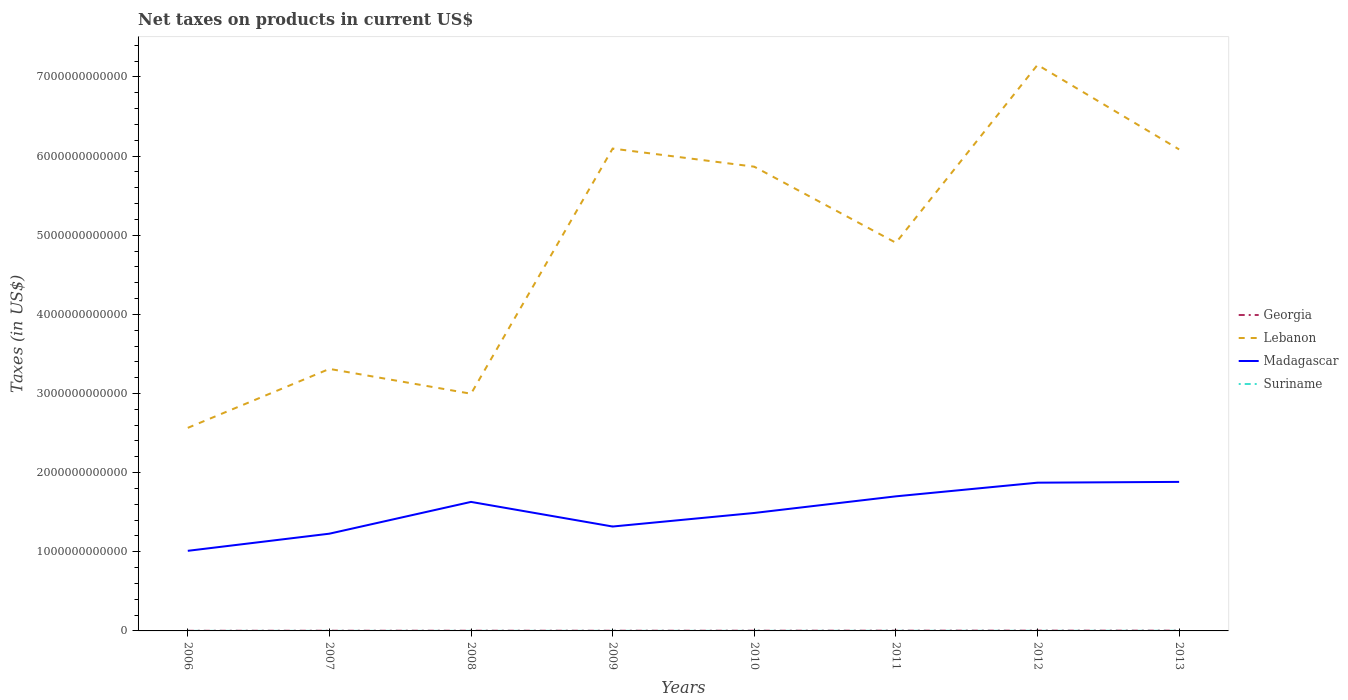Does the line corresponding to Georgia intersect with the line corresponding to Madagascar?
Offer a very short reply. No. Is the number of lines equal to the number of legend labels?
Offer a terse response. Yes. Across all years, what is the maximum net taxes on products in Lebanon?
Ensure brevity in your answer.  2.57e+12. What is the total net taxes on products in Suriname in the graph?
Give a very brief answer. -8.75e+08. What is the difference between the highest and the second highest net taxes on products in Madagascar?
Keep it short and to the point. 8.71e+11. What is the difference between the highest and the lowest net taxes on products in Suriname?
Your response must be concise. 3. Is the net taxes on products in Georgia strictly greater than the net taxes on products in Madagascar over the years?
Provide a succinct answer. Yes. How many years are there in the graph?
Provide a succinct answer. 8. What is the difference between two consecutive major ticks on the Y-axis?
Make the answer very short. 1.00e+12. Does the graph contain any zero values?
Provide a short and direct response. No. Does the graph contain grids?
Give a very brief answer. No. Where does the legend appear in the graph?
Offer a terse response. Center right. How many legend labels are there?
Your response must be concise. 4. How are the legend labels stacked?
Make the answer very short. Vertical. What is the title of the graph?
Your response must be concise. Net taxes on products in current US$. Does "Monaco" appear as one of the legend labels in the graph?
Provide a succinct answer. No. What is the label or title of the X-axis?
Provide a succinct answer. Years. What is the label or title of the Y-axis?
Your answer should be very brief. Taxes (in US$). What is the Taxes (in US$) of Georgia in 2006?
Provide a succinct answer. 1.74e+09. What is the Taxes (in US$) in Lebanon in 2006?
Ensure brevity in your answer.  2.57e+12. What is the Taxes (in US$) of Madagascar in 2006?
Give a very brief answer. 1.01e+12. What is the Taxes (in US$) in Suriname in 2006?
Make the answer very short. 5.51e+08. What is the Taxes (in US$) of Georgia in 2007?
Offer a terse response. 2.38e+09. What is the Taxes (in US$) in Lebanon in 2007?
Provide a short and direct response. 3.31e+12. What is the Taxes (in US$) in Madagascar in 2007?
Keep it short and to the point. 1.23e+12. What is the Taxes (in US$) in Suriname in 2007?
Keep it short and to the point. 6.48e+08. What is the Taxes (in US$) in Georgia in 2008?
Offer a terse response. 2.55e+09. What is the Taxes (in US$) of Lebanon in 2008?
Your response must be concise. 3.00e+12. What is the Taxes (in US$) of Madagascar in 2008?
Provide a short and direct response. 1.63e+12. What is the Taxes (in US$) in Suriname in 2008?
Ensure brevity in your answer.  6.62e+08. What is the Taxes (in US$) in Georgia in 2009?
Offer a very short reply. 2.44e+09. What is the Taxes (in US$) in Lebanon in 2009?
Keep it short and to the point. 6.10e+12. What is the Taxes (in US$) in Madagascar in 2009?
Ensure brevity in your answer.  1.32e+12. What is the Taxes (in US$) of Suriname in 2009?
Offer a terse response. 8.69e+08. What is the Taxes (in US$) in Georgia in 2010?
Provide a short and direct response. 2.73e+09. What is the Taxes (in US$) in Lebanon in 2010?
Make the answer very short. 5.87e+12. What is the Taxes (in US$) of Madagascar in 2010?
Your response must be concise. 1.49e+12. What is the Taxes (in US$) in Suriname in 2010?
Your answer should be compact. 8.55e+08. What is the Taxes (in US$) of Georgia in 2011?
Offer a terse response. 3.37e+09. What is the Taxes (in US$) in Lebanon in 2011?
Your response must be concise. 4.90e+12. What is the Taxes (in US$) of Madagascar in 2011?
Your response must be concise. 1.70e+12. What is the Taxes (in US$) in Suriname in 2011?
Give a very brief answer. 1.32e+09. What is the Taxes (in US$) of Georgia in 2012?
Your answer should be very brief. 3.66e+09. What is the Taxes (in US$) of Lebanon in 2012?
Offer a very short reply. 7.15e+12. What is the Taxes (in US$) in Madagascar in 2012?
Make the answer very short. 1.87e+12. What is the Taxes (in US$) in Suriname in 2012?
Your response must be concise. 1.43e+09. What is the Taxes (in US$) of Georgia in 2013?
Provide a succinct answer. 3.51e+09. What is the Taxes (in US$) in Lebanon in 2013?
Offer a very short reply. 6.08e+12. What is the Taxes (in US$) of Madagascar in 2013?
Your response must be concise. 1.88e+12. What is the Taxes (in US$) in Suriname in 2013?
Provide a short and direct response. 1.54e+09. Across all years, what is the maximum Taxes (in US$) in Georgia?
Provide a short and direct response. 3.66e+09. Across all years, what is the maximum Taxes (in US$) of Lebanon?
Your answer should be compact. 7.15e+12. Across all years, what is the maximum Taxes (in US$) of Madagascar?
Provide a succinct answer. 1.88e+12. Across all years, what is the maximum Taxes (in US$) in Suriname?
Keep it short and to the point. 1.54e+09. Across all years, what is the minimum Taxes (in US$) in Georgia?
Keep it short and to the point. 1.74e+09. Across all years, what is the minimum Taxes (in US$) in Lebanon?
Provide a short and direct response. 2.57e+12. Across all years, what is the minimum Taxes (in US$) of Madagascar?
Provide a short and direct response. 1.01e+12. Across all years, what is the minimum Taxes (in US$) of Suriname?
Offer a terse response. 5.51e+08. What is the total Taxes (in US$) in Georgia in the graph?
Your answer should be compact. 2.24e+1. What is the total Taxes (in US$) of Lebanon in the graph?
Offer a terse response. 3.90e+13. What is the total Taxes (in US$) in Madagascar in the graph?
Keep it short and to the point. 1.21e+13. What is the total Taxes (in US$) in Suriname in the graph?
Make the answer very short. 7.87e+09. What is the difference between the Taxes (in US$) of Georgia in 2006 and that in 2007?
Provide a short and direct response. -6.40e+08. What is the difference between the Taxes (in US$) in Lebanon in 2006 and that in 2007?
Make the answer very short. -7.45e+11. What is the difference between the Taxes (in US$) of Madagascar in 2006 and that in 2007?
Ensure brevity in your answer.  -2.17e+11. What is the difference between the Taxes (in US$) in Suriname in 2006 and that in 2007?
Give a very brief answer. -9.70e+07. What is the difference between the Taxes (in US$) in Georgia in 2006 and that in 2008?
Give a very brief answer. -8.10e+08. What is the difference between the Taxes (in US$) in Lebanon in 2006 and that in 2008?
Your answer should be compact. -4.31e+11. What is the difference between the Taxes (in US$) in Madagascar in 2006 and that in 2008?
Your response must be concise. -6.18e+11. What is the difference between the Taxes (in US$) of Suriname in 2006 and that in 2008?
Keep it short and to the point. -1.11e+08. What is the difference between the Taxes (in US$) in Georgia in 2006 and that in 2009?
Keep it short and to the point. -6.97e+08. What is the difference between the Taxes (in US$) in Lebanon in 2006 and that in 2009?
Make the answer very short. -3.53e+12. What is the difference between the Taxes (in US$) of Madagascar in 2006 and that in 2009?
Your answer should be compact. -3.07e+11. What is the difference between the Taxes (in US$) in Suriname in 2006 and that in 2009?
Offer a very short reply. -3.18e+08. What is the difference between the Taxes (in US$) in Georgia in 2006 and that in 2010?
Ensure brevity in your answer.  -9.86e+08. What is the difference between the Taxes (in US$) in Lebanon in 2006 and that in 2010?
Keep it short and to the point. -3.30e+12. What is the difference between the Taxes (in US$) of Madagascar in 2006 and that in 2010?
Give a very brief answer. -4.78e+11. What is the difference between the Taxes (in US$) in Suriname in 2006 and that in 2010?
Make the answer very short. -3.04e+08. What is the difference between the Taxes (in US$) of Georgia in 2006 and that in 2011?
Give a very brief answer. -1.63e+09. What is the difference between the Taxes (in US$) of Lebanon in 2006 and that in 2011?
Your answer should be compact. -2.34e+12. What is the difference between the Taxes (in US$) in Madagascar in 2006 and that in 2011?
Give a very brief answer. -6.89e+11. What is the difference between the Taxes (in US$) of Suriname in 2006 and that in 2011?
Keep it short and to the point. -7.68e+08. What is the difference between the Taxes (in US$) of Georgia in 2006 and that in 2012?
Give a very brief answer. -1.92e+09. What is the difference between the Taxes (in US$) of Lebanon in 2006 and that in 2012?
Your answer should be compact. -4.59e+12. What is the difference between the Taxes (in US$) of Madagascar in 2006 and that in 2012?
Keep it short and to the point. -8.61e+11. What is the difference between the Taxes (in US$) in Suriname in 2006 and that in 2012?
Give a very brief answer. -8.75e+08. What is the difference between the Taxes (in US$) in Georgia in 2006 and that in 2013?
Make the answer very short. -1.77e+09. What is the difference between the Taxes (in US$) in Lebanon in 2006 and that in 2013?
Provide a short and direct response. -3.52e+12. What is the difference between the Taxes (in US$) of Madagascar in 2006 and that in 2013?
Provide a succinct answer. -8.71e+11. What is the difference between the Taxes (in US$) in Suriname in 2006 and that in 2013?
Your answer should be very brief. -9.91e+08. What is the difference between the Taxes (in US$) of Georgia in 2007 and that in 2008?
Offer a terse response. -1.70e+08. What is the difference between the Taxes (in US$) of Lebanon in 2007 and that in 2008?
Keep it short and to the point. 3.14e+11. What is the difference between the Taxes (in US$) of Madagascar in 2007 and that in 2008?
Ensure brevity in your answer.  -4.02e+11. What is the difference between the Taxes (in US$) in Suriname in 2007 and that in 2008?
Make the answer very short. -1.40e+07. What is the difference between the Taxes (in US$) in Georgia in 2007 and that in 2009?
Your answer should be compact. -5.69e+07. What is the difference between the Taxes (in US$) in Lebanon in 2007 and that in 2009?
Your answer should be very brief. -2.78e+12. What is the difference between the Taxes (in US$) in Madagascar in 2007 and that in 2009?
Ensure brevity in your answer.  -9.04e+1. What is the difference between the Taxes (in US$) of Suriname in 2007 and that in 2009?
Keep it short and to the point. -2.21e+08. What is the difference between the Taxes (in US$) in Georgia in 2007 and that in 2010?
Offer a very short reply. -3.46e+08. What is the difference between the Taxes (in US$) in Lebanon in 2007 and that in 2010?
Offer a terse response. -2.56e+12. What is the difference between the Taxes (in US$) of Madagascar in 2007 and that in 2010?
Ensure brevity in your answer.  -2.62e+11. What is the difference between the Taxes (in US$) of Suriname in 2007 and that in 2010?
Make the answer very short. -2.07e+08. What is the difference between the Taxes (in US$) in Georgia in 2007 and that in 2011?
Your answer should be compact. -9.86e+08. What is the difference between the Taxes (in US$) in Lebanon in 2007 and that in 2011?
Keep it short and to the point. -1.59e+12. What is the difference between the Taxes (in US$) in Madagascar in 2007 and that in 2011?
Give a very brief answer. -4.72e+11. What is the difference between the Taxes (in US$) in Suriname in 2007 and that in 2011?
Your answer should be very brief. -6.71e+08. What is the difference between the Taxes (in US$) in Georgia in 2007 and that in 2012?
Ensure brevity in your answer.  -1.28e+09. What is the difference between the Taxes (in US$) in Lebanon in 2007 and that in 2012?
Keep it short and to the point. -3.84e+12. What is the difference between the Taxes (in US$) of Madagascar in 2007 and that in 2012?
Make the answer very short. -6.45e+11. What is the difference between the Taxes (in US$) in Suriname in 2007 and that in 2012?
Offer a very short reply. -7.78e+08. What is the difference between the Taxes (in US$) in Georgia in 2007 and that in 2013?
Your answer should be compact. -1.13e+09. What is the difference between the Taxes (in US$) in Lebanon in 2007 and that in 2013?
Ensure brevity in your answer.  -2.77e+12. What is the difference between the Taxes (in US$) in Madagascar in 2007 and that in 2013?
Offer a very short reply. -6.54e+11. What is the difference between the Taxes (in US$) in Suriname in 2007 and that in 2013?
Provide a succinct answer. -8.94e+08. What is the difference between the Taxes (in US$) of Georgia in 2008 and that in 2009?
Offer a terse response. 1.13e+08. What is the difference between the Taxes (in US$) in Lebanon in 2008 and that in 2009?
Your response must be concise. -3.10e+12. What is the difference between the Taxes (in US$) of Madagascar in 2008 and that in 2009?
Make the answer very short. 3.11e+11. What is the difference between the Taxes (in US$) of Suriname in 2008 and that in 2009?
Your answer should be very brief. -2.07e+08. What is the difference between the Taxes (in US$) in Georgia in 2008 and that in 2010?
Your answer should be very brief. -1.76e+08. What is the difference between the Taxes (in US$) in Lebanon in 2008 and that in 2010?
Offer a terse response. -2.87e+12. What is the difference between the Taxes (in US$) of Madagascar in 2008 and that in 2010?
Ensure brevity in your answer.  1.40e+11. What is the difference between the Taxes (in US$) of Suriname in 2008 and that in 2010?
Provide a succinct answer. -1.93e+08. What is the difference between the Taxes (in US$) in Georgia in 2008 and that in 2011?
Your response must be concise. -8.16e+08. What is the difference between the Taxes (in US$) in Lebanon in 2008 and that in 2011?
Offer a very short reply. -1.91e+12. What is the difference between the Taxes (in US$) in Madagascar in 2008 and that in 2011?
Make the answer very short. -7.04e+1. What is the difference between the Taxes (in US$) in Suriname in 2008 and that in 2011?
Ensure brevity in your answer.  -6.57e+08. What is the difference between the Taxes (in US$) in Georgia in 2008 and that in 2012?
Your answer should be compact. -1.11e+09. What is the difference between the Taxes (in US$) in Lebanon in 2008 and that in 2012?
Offer a terse response. -4.16e+12. What is the difference between the Taxes (in US$) in Madagascar in 2008 and that in 2012?
Give a very brief answer. -2.43e+11. What is the difference between the Taxes (in US$) in Suriname in 2008 and that in 2012?
Provide a short and direct response. -7.64e+08. What is the difference between the Taxes (in US$) in Georgia in 2008 and that in 2013?
Ensure brevity in your answer.  -9.59e+08. What is the difference between the Taxes (in US$) of Lebanon in 2008 and that in 2013?
Offer a terse response. -3.09e+12. What is the difference between the Taxes (in US$) of Madagascar in 2008 and that in 2013?
Ensure brevity in your answer.  -2.53e+11. What is the difference between the Taxes (in US$) of Suriname in 2008 and that in 2013?
Offer a very short reply. -8.80e+08. What is the difference between the Taxes (in US$) in Georgia in 2009 and that in 2010?
Provide a succinct answer. -2.89e+08. What is the difference between the Taxes (in US$) of Lebanon in 2009 and that in 2010?
Give a very brief answer. 2.29e+11. What is the difference between the Taxes (in US$) of Madagascar in 2009 and that in 2010?
Provide a succinct answer. -1.71e+11. What is the difference between the Taxes (in US$) in Suriname in 2009 and that in 2010?
Offer a very short reply. 1.40e+07. What is the difference between the Taxes (in US$) of Georgia in 2009 and that in 2011?
Keep it short and to the point. -9.29e+08. What is the difference between the Taxes (in US$) of Lebanon in 2009 and that in 2011?
Offer a terse response. 1.19e+12. What is the difference between the Taxes (in US$) of Madagascar in 2009 and that in 2011?
Your answer should be very brief. -3.81e+11. What is the difference between the Taxes (in US$) in Suriname in 2009 and that in 2011?
Your answer should be very brief. -4.50e+08. What is the difference between the Taxes (in US$) in Georgia in 2009 and that in 2012?
Your response must be concise. -1.22e+09. What is the difference between the Taxes (in US$) in Lebanon in 2009 and that in 2012?
Your answer should be compact. -1.06e+12. What is the difference between the Taxes (in US$) of Madagascar in 2009 and that in 2012?
Provide a short and direct response. -5.54e+11. What is the difference between the Taxes (in US$) of Suriname in 2009 and that in 2012?
Offer a very short reply. -5.57e+08. What is the difference between the Taxes (in US$) in Georgia in 2009 and that in 2013?
Ensure brevity in your answer.  -1.07e+09. What is the difference between the Taxes (in US$) in Lebanon in 2009 and that in 2013?
Provide a short and direct response. 1.06e+1. What is the difference between the Taxes (in US$) in Madagascar in 2009 and that in 2013?
Ensure brevity in your answer.  -5.64e+11. What is the difference between the Taxes (in US$) in Suriname in 2009 and that in 2013?
Keep it short and to the point. -6.73e+08. What is the difference between the Taxes (in US$) of Georgia in 2010 and that in 2011?
Offer a very short reply. -6.40e+08. What is the difference between the Taxes (in US$) of Lebanon in 2010 and that in 2011?
Your answer should be very brief. 9.61e+11. What is the difference between the Taxes (in US$) in Madagascar in 2010 and that in 2011?
Give a very brief answer. -2.10e+11. What is the difference between the Taxes (in US$) in Suriname in 2010 and that in 2011?
Make the answer very short. -4.64e+08. What is the difference between the Taxes (in US$) in Georgia in 2010 and that in 2012?
Your response must be concise. -9.33e+08. What is the difference between the Taxes (in US$) in Lebanon in 2010 and that in 2012?
Ensure brevity in your answer.  -1.29e+12. What is the difference between the Taxes (in US$) of Madagascar in 2010 and that in 2012?
Keep it short and to the point. -3.83e+11. What is the difference between the Taxes (in US$) of Suriname in 2010 and that in 2012?
Make the answer very short. -5.71e+08. What is the difference between the Taxes (in US$) in Georgia in 2010 and that in 2013?
Make the answer very short. -7.83e+08. What is the difference between the Taxes (in US$) in Lebanon in 2010 and that in 2013?
Make the answer very short. -2.18e+11. What is the difference between the Taxes (in US$) in Madagascar in 2010 and that in 2013?
Your answer should be compact. -3.93e+11. What is the difference between the Taxes (in US$) in Suriname in 2010 and that in 2013?
Provide a short and direct response. -6.87e+08. What is the difference between the Taxes (in US$) of Georgia in 2011 and that in 2012?
Offer a very short reply. -2.93e+08. What is the difference between the Taxes (in US$) of Lebanon in 2011 and that in 2012?
Offer a very short reply. -2.25e+12. What is the difference between the Taxes (in US$) of Madagascar in 2011 and that in 2012?
Your answer should be compact. -1.73e+11. What is the difference between the Taxes (in US$) of Suriname in 2011 and that in 2012?
Give a very brief answer. -1.07e+08. What is the difference between the Taxes (in US$) in Georgia in 2011 and that in 2013?
Offer a terse response. -1.44e+08. What is the difference between the Taxes (in US$) of Lebanon in 2011 and that in 2013?
Make the answer very short. -1.18e+12. What is the difference between the Taxes (in US$) in Madagascar in 2011 and that in 2013?
Offer a terse response. -1.83e+11. What is the difference between the Taxes (in US$) of Suriname in 2011 and that in 2013?
Give a very brief answer. -2.23e+08. What is the difference between the Taxes (in US$) in Georgia in 2012 and that in 2013?
Offer a terse response. 1.50e+08. What is the difference between the Taxes (in US$) of Lebanon in 2012 and that in 2013?
Ensure brevity in your answer.  1.07e+12. What is the difference between the Taxes (in US$) of Madagascar in 2012 and that in 2013?
Provide a short and direct response. -9.89e+09. What is the difference between the Taxes (in US$) of Suriname in 2012 and that in 2013?
Your answer should be very brief. -1.16e+08. What is the difference between the Taxes (in US$) in Georgia in 2006 and the Taxes (in US$) in Lebanon in 2007?
Provide a short and direct response. -3.31e+12. What is the difference between the Taxes (in US$) of Georgia in 2006 and the Taxes (in US$) of Madagascar in 2007?
Ensure brevity in your answer.  -1.23e+12. What is the difference between the Taxes (in US$) of Georgia in 2006 and the Taxes (in US$) of Suriname in 2007?
Keep it short and to the point. 1.10e+09. What is the difference between the Taxes (in US$) in Lebanon in 2006 and the Taxes (in US$) in Madagascar in 2007?
Make the answer very short. 1.34e+12. What is the difference between the Taxes (in US$) of Lebanon in 2006 and the Taxes (in US$) of Suriname in 2007?
Offer a very short reply. 2.57e+12. What is the difference between the Taxes (in US$) of Madagascar in 2006 and the Taxes (in US$) of Suriname in 2007?
Offer a very short reply. 1.01e+12. What is the difference between the Taxes (in US$) in Georgia in 2006 and the Taxes (in US$) in Lebanon in 2008?
Your answer should be compact. -3.00e+12. What is the difference between the Taxes (in US$) in Georgia in 2006 and the Taxes (in US$) in Madagascar in 2008?
Offer a terse response. -1.63e+12. What is the difference between the Taxes (in US$) of Georgia in 2006 and the Taxes (in US$) of Suriname in 2008?
Provide a succinct answer. 1.08e+09. What is the difference between the Taxes (in US$) in Lebanon in 2006 and the Taxes (in US$) in Madagascar in 2008?
Your answer should be compact. 9.36e+11. What is the difference between the Taxes (in US$) in Lebanon in 2006 and the Taxes (in US$) in Suriname in 2008?
Your answer should be compact. 2.57e+12. What is the difference between the Taxes (in US$) of Madagascar in 2006 and the Taxes (in US$) of Suriname in 2008?
Your response must be concise. 1.01e+12. What is the difference between the Taxes (in US$) of Georgia in 2006 and the Taxes (in US$) of Lebanon in 2009?
Give a very brief answer. -6.09e+12. What is the difference between the Taxes (in US$) in Georgia in 2006 and the Taxes (in US$) in Madagascar in 2009?
Give a very brief answer. -1.32e+12. What is the difference between the Taxes (in US$) of Georgia in 2006 and the Taxes (in US$) of Suriname in 2009?
Ensure brevity in your answer.  8.74e+08. What is the difference between the Taxes (in US$) in Lebanon in 2006 and the Taxes (in US$) in Madagascar in 2009?
Offer a terse response. 1.25e+12. What is the difference between the Taxes (in US$) of Lebanon in 2006 and the Taxes (in US$) of Suriname in 2009?
Make the answer very short. 2.57e+12. What is the difference between the Taxes (in US$) of Madagascar in 2006 and the Taxes (in US$) of Suriname in 2009?
Provide a succinct answer. 1.01e+12. What is the difference between the Taxes (in US$) of Georgia in 2006 and the Taxes (in US$) of Lebanon in 2010?
Give a very brief answer. -5.86e+12. What is the difference between the Taxes (in US$) in Georgia in 2006 and the Taxes (in US$) in Madagascar in 2010?
Your answer should be very brief. -1.49e+12. What is the difference between the Taxes (in US$) of Georgia in 2006 and the Taxes (in US$) of Suriname in 2010?
Ensure brevity in your answer.  8.88e+08. What is the difference between the Taxes (in US$) in Lebanon in 2006 and the Taxes (in US$) in Madagascar in 2010?
Give a very brief answer. 1.08e+12. What is the difference between the Taxes (in US$) in Lebanon in 2006 and the Taxes (in US$) in Suriname in 2010?
Provide a short and direct response. 2.57e+12. What is the difference between the Taxes (in US$) of Madagascar in 2006 and the Taxes (in US$) of Suriname in 2010?
Give a very brief answer. 1.01e+12. What is the difference between the Taxes (in US$) of Georgia in 2006 and the Taxes (in US$) of Lebanon in 2011?
Provide a short and direct response. -4.90e+12. What is the difference between the Taxes (in US$) in Georgia in 2006 and the Taxes (in US$) in Madagascar in 2011?
Make the answer very short. -1.70e+12. What is the difference between the Taxes (in US$) of Georgia in 2006 and the Taxes (in US$) of Suriname in 2011?
Offer a terse response. 4.24e+08. What is the difference between the Taxes (in US$) of Lebanon in 2006 and the Taxes (in US$) of Madagascar in 2011?
Keep it short and to the point. 8.65e+11. What is the difference between the Taxes (in US$) in Lebanon in 2006 and the Taxes (in US$) in Suriname in 2011?
Provide a succinct answer. 2.56e+12. What is the difference between the Taxes (in US$) in Madagascar in 2006 and the Taxes (in US$) in Suriname in 2011?
Make the answer very short. 1.01e+12. What is the difference between the Taxes (in US$) in Georgia in 2006 and the Taxes (in US$) in Lebanon in 2012?
Offer a terse response. -7.15e+12. What is the difference between the Taxes (in US$) in Georgia in 2006 and the Taxes (in US$) in Madagascar in 2012?
Provide a short and direct response. -1.87e+12. What is the difference between the Taxes (in US$) in Georgia in 2006 and the Taxes (in US$) in Suriname in 2012?
Offer a very short reply. 3.17e+08. What is the difference between the Taxes (in US$) in Lebanon in 2006 and the Taxes (in US$) in Madagascar in 2012?
Offer a terse response. 6.93e+11. What is the difference between the Taxes (in US$) in Lebanon in 2006 and the Taxes (in US$) in Suriname in 2012?
Offer a terse response. 2.56e+12. What is the difference between the Taxes (in US$) in Madagascar in 2006 and the Taxes (in US$) in Suriname in 2012?
Your answer should be very brief. 1.01e+12. What is the difference between the Taxes (in US$) in Georgia in 2006 and the Taxes (in US$) in Lebanon in 2013?
Offer a very short reply. -6.08e+12. What is the difference between the Taxes (in US$) in Georgia in 2006 and the Taxes (in US$) in Madagascar in 2013?
Make the answer very short. -1.88e+12. What is the difference between the Taxes (in US$) of Georgia in 2006 and the Taxes (in US$) of Suriname in 2013?
Offer a terse response. 2.01e+08. What is the difference between the Taxes (in US$) of Lebanon in 2006 and the Taxes (in US$) of Madagascar in 2013?
Offer a terse response. 6.83e+11. What is the difference between the Taxes (in US$) in Lebanon in 2006 and the Taxes (in US$) in Suriname in 2013?
Offer a terse response. 2.56e+12. What is the difference between the Taxes (in US$) of Madagascar in 2006 and the Taxes (in US$) of Suriname in 2013?
Offer a terse response. 1.01e+12. What is the difference between the Taxes (in US$) in Georgia in 2007 and the Taxes (in US$) in Lebanon in 2008?
Your answer should be compact. -2.99e+12. What is the difference between the Taxes (in US$) of Georgia in 2007 and the Taxes (in US$) of Madagascar in 2008?
Offer a terse response. -1.63e+12. What is the difference between the Taxes (in US$) in Georgia in 2007 and the Taxes (in US$) in Suriname in 2008?
Keep it short and to the point. 1.72e+09. What is the difference between the Taxes (in US$) in Lebanon in 2007 and the Taxes (in US$) in Madagascar in 2008?
Ensure brevity in your answer.  1.68e+12. What is the difference between the Taxes (in US$) of Lebanon in 2007 and the Taxes (in US$) of Suriname in 2008?
Your response must be concise. 3.31e+12. What is the difference between the Taxes (in US$) of Madagascar in 2007 and the Taxes (in US$) of Suriname in 2008?
Offer a terse response. 1.23e+12. What is the difference between the Taxes (in US$) of Georgia in 2007 and the Taxes (in US$) of Lebanon in 2009?
Provide a short and direct response. -6.09e+12. What is the difference between the Taxes (in US$) of Georgia in 2007 and the Taxes (in US$) of Madagascar in 2009?
Offer a terse response. -1.32e+12. What is the difference between the Taxes (in US$) in Georgia in 2007 and the Taxes (in US$) in Suriname in 2009?
Your response must be concise. 1.51e+09. What is the difference between the Taxes (in US$) of Lebanon in 2007 and the Taxes (in US$) of Madagascar in 2009?
Your response must be concise. 1.99e+12. What is the difference between the Taxes (in US$) in Lebanon in 2007 and the Taxes (in US$) in Suriname in 2009?
Provide a short and direct response. 3.31e+12. What is the difference between the Taxes (in US$) in Madagascar in 2007 and the Taxes (in US$) in Suriname in 2009?
Make the answer very short. 1.23e+12. What is the difference between the Taxes (in US$) of Georgia in 2007 and the Taxes (in US$) of Lebanon in 2010?
Offer a terse response. -5.86e+12. What is the difference between the Taxes (in US$) of Georgia in 2007 and the Taxes (in US$) of Madagascar in 2010?
Ensure brevity in your answer.  -1.49e+12. What is the difference between the Taxes (in US$) in Georgia in 2007 and the Taxes (in US$) in Suriname in 2010?
Make the answer very short. 1.53e+09. What is the difference between the Taxes (in US$) of Lebanon in 2007 and the Taxes (in US$) of Madagascar in 2010?
Your answer should be very brief. 1.82e+12. What is the difference between the Taxes (in US$) in Lebanon in 2007 and the Taxes (in US$) in Suriname in 2010?
Offer a very short reply. 3.31e+12. What is the difference between the Taxes (in US$) in Madagascar in 2007 and the Taxes (in US$) in Suriname in 2010?
Keep it short and to the point. 1.23e+12. What is the difference between the Taxes (in US$) in Georgia in 2007 and the Taxes (in US$) in Lebanon in 2011?
Provide a short and direct response. -4.90e+12. What is the difference between the Taxes (in US$) of Georgia in 2007 and the Taxes (in US$) of Madagascar in 2011?
Your answer should be compact. -1.70e+12. What is the difference between the Taxes (in US$) of Georgia in 2007 and the Taxes (in US$) of Suriname in 2011?
Ensure brevity in your answer.  1.06e+09. What is the difference between the Taxes (in US$) of Lebanon in 2007 and the Taxes (in US$) of Madagascar in 2011?
Provide a succinct answer. 1.61e+12. What is the difference between the Taxes (in US$) in Lebanon in 2007 and the Taxes (in US$) in Suriname in 2011?
Your response must be concise. 3.31e+12. What is the difference between the Taxes (in US$) in Madagascar in 2007 and the Taxes (in US$) in Suriname in 2011?
Offer a very short reply. 1.23e+12. What is the difference between the Taxes (in US$) in Georgia in 2007 and the Taxes (in US$) in Lebanon in 2012?
Keep it short and to the point. -7.15e+12. What is the difference between the Taxes (in US$) in Georgia in 2007 and the Taxes (in US$) in Madagascar in 2012?
Make the answer very short. -1.87e+12. What is the difference between the Taxes (in US$) of Georgia in 2007 and the Taxes (in US$) of Suriname in 2012?
Offer a terse response. 9.57e+08. What is the difference between the Taxes (in US$) in Lebanon in 2007 and the Taxes (in US$) in Madagascar in 2012?
Provide a short and direct response. 1.44e+12. What is the difference between the Taxes (in US$) of Lebanon in 2007 and the Taxes (in US$) of Suriname in 2012?
Provide a short and direct response. 3.31e+12. What is the difference between the Taxes (in US$) in Madagascar in 2007 and the Taxes (in US$) in Suriname in 2012?
Ensure brevity in your answer.  1.23e+12. What is the difference between the Taxes (in US$) of Georgia in 2007 and the Taxes (in US$) of Lebanon in 2013?
Provide a succinct answer. -6.08e+12. What is the difference between the Taxes (in US$) of Georgia in 2007 and the Taxes (in US$) of Madagascar in 2013?
Provide a succinct answer. -1.88e+12. What is the difference between the Taxes (in US$) in Georgia in 2007 and the Taxes (in US$) in Suriname in 2013?
Offer a very short reply. 8.41e+08. What is the difference between the Taxes (in US$) in Lebanon in 2007 and the Taxes (in US$) in Madagascar in 2013?
Offer a very short reply. 1.43e+12. What is the difference between the Taxes (in US$) of Lebanon in 2007 and the Taxes (in US$) of Suriname in 2013?
Your answer should be compact. 3.31e+12. What is the difference between the Taxes (in US$) of Madagascar in 2007 and the Taxes (in US$) of Suriname in 2013?
Keep it short and to the point. 1.23e+12. What is the difference between the Taxes (in US$) in Georgia in 2008 and the Taxes (in US$) in Lebanon in 2009?
Ensure brevity in your answer.  -6.09e+12. What is the difference between the Taxes (in US$) in Georgia in 2008 and the Taxes (in US$) in Madagascar in 2009?
Provide a short and direct response. -1.32e+12. What is the difference between the Taxes (in US$) of Georgia in 2008 and the Taxes (in US$) of Suriname in 2009?
Give a very brief answer. 1.68e+09. What is the difference between the Taxes (in US$) of Lebanon in 2008 and the Taxes (in US$) of Madagascar in 2009?
Keep it short and to the point. 1.68e+12. What is the difference between the Taxes (in US$) in Lebanon in 2008 and the Taxes (in US$) in Suriname in 2009?
Provide a succinct answer. 3.00e+12. What is the difference between the Taxes (in US$) of Madagascar in 2008 and the Taxes (in US$) of Suriname in 2009?
Keep it short and to the point. 1.63e+12. What is the difference between the Taxes (in US$) in Georgia in 2008 and the Taxes (in US$) in Lebanon in 2010?
Make the answer very short. -5.86e+12. What is the difference between the Taxes (in US$) in Georgia in 2008 and the Taxes (in US$) in Madagascar in 2010?
Keep it short and to the point. -1.49e+12. What is the difference between the Taxes (in US$) in Georgia in 2008 and the Taxes (in US$) in Suriname in 2010?
Offer a terse response. 1.70e+09. What is the difference between the Taxes (in US$) of Lebanon in 2008 and the Taxes (in US$) of Madagascar in 2010?
Keep it short and to the point. 1.51e+12. What is the difference between the Taxes (in US$) of Lebanon in 2008 and the Taxes (in US$) of Suriname in 2010?
Keep it short and to the point. 3.00e+12. What is the difference between the Taxes (in US$) of Madagascar in 2008 and the Taxes (in US$) of Suriname in 2010?
Your answer should be compact. 1.63e+12. What is the difference between the Taxes (in US$) of Georgia in 2008 and the Taxes (in US$) of Lebanon in 2011?
Make the answer very short. -4.90e+12. What is the difference between the Taxes (in US$) in Georgia in 2008 and the Taxes (in US$) in Madagascar in 2011?
Offer a terse response. -1.70e+12. What is the difference between the Taxes (in US$) of Georgia in 2008 and the Taxes (in US$) of Suriname in 2011?
Your response must be concise. 1.23e+09. What is the difference between the Taxes (in US$) of Lebanon in 2008 and the Taxes (in US$) of Madagascar in 2011?
Offer a very short reply. 1.30e+12. What is the difference between the Taxes (in US$) in Lebanon in 2008 and the Taxes (in US$) in Suriname in 2011?
Give a very brief answer. 3.00e+12. What is the difference between the Taxes (in US$) in Madagascar in 2008 and the Taxes (in US$) in Suriname in 2011?
Keep it short and to the point. 1.63e+12. What is the difference between the Taxes (in US$) of Georgia in 2008 and the Taxes (in US$) of Lebanon in 2012?
Provide a short and direct response. -7.15e+12. What is the difference between the Taxes (in US$) in Georgia in 2008 and the Taxes (in US$) in Madagascar in 2012?
Give a very brief answer. -1.87e+12. What is the difference between the Taxes (in US$) in Georgia in 2008 and the Taxes (in US$) in Suriname in 2012?
Make the answer very short. 1.13e+09. What is the difference between the Taxes (in US$) in Lebanon in 2008 and the Taxes (in US$) in Madagascar in 2012?
Make the answer very short. 1.12e+12. What is the difference between the Taxes (in US$) of Lebanon in 2008 and the Taxes (in US$) of Suriname in 2012?
Your response must be concise. 3.00e+12. What is the difference between the Taxes (in US$) of Madagascar in 2008 and the Taxes (in US$) of Suriname in 2012?
Give a very brief answer. 1.63e+12. What is the difference between the Taxes (in US$) in Georgia in 2008 and the Taxes (in US$) in Lebanon in 2013?
Your answer should be very brief. -6.08e+12. What is the difference between the Taxes (in US$) of Georgia in 2008 and the Taxes (in US$) of Madagascar in 2013?
Your response must be concise. -1.88e+12. What is the difference between the Taxes (in US$) of Georgia in 2008 and the Taxes (in US$) of Suriname in 2013?
Offer a terse response. 1.01e+09. What is the difference between the Taxes (in US$) of Lebanon in 2008 and the Taxes (in US$) of Madagascar in 2013?
Your answer should be compact. 1.11e+12. What is the difference between the Taxes (in US$) of Lebanon in 2008 and the Taxes (in US$) of Suriname in 2013?
Provide a short and direct response. 3.00e+12. What is the difference between the Taxes (in US$) in Madagascar in 2008 and the Taxes (in US$) in Suriname in 2013?
Provide a succinct answer. 1.63e+12. What is the difference between the Taxes (in US$) in Georgia in 2009 and the Taxes (in US$) in Lebanon in 2010?
Provide a succinct answer. -5.86e+12. What is the difference between the Taxes (in US$) of Georgia in 2009 and the Taxes (in US$) of Madagascar in 2010?
Your response must be concise. -1.49e+12. What is the difference between the Taxes (in US$) of Georgia in 2009 and the Taxes (in US$) of Suriname in 2010?
Provide a short and direct response. 1.58e+09. What is the difference between the Taxes (in US$) of Lebanon in 2009 and the Taxes (in US$) of Madagascar in 2010?
Offer a very short reply. 4.60e+12. What is the difference between the Taxes (in US$) in Lebanon in 2009 and the Taxes (in US$) in Suriname in 2010?
Your answer should be compact. 6.09e+12. What is the difference between the Taxes (in US$) of Madagascar in 2009 and the Taxes (in US$) of Suriname in 2010?
Offer a very short reply. 1.32e+12. What is the difference between the Taxes (in US$) of Georgia in 2009 and the Taxes (in US$) of Lebanon in 2011?
Ensure brevity in your answer.  -4.90e+12. What is the difference between the Taxes (in US$) in Georgia in 2009 and the Taxes (in US$) in Madagascar in 2011?
Offer a very short reply. -1.70e+12. What is the difference between the Taxes (in US$) of Georgia in 2009 and the Taxes (in US$) of Suriname in 2011?
Ensure brevity in your answer.  1.12e+09. What is the difference between the Taxes (in US$) in Lebanon in 2009 and the Taxes (in US$) in Madagascar in 2011?
Offer a terse response. 4.39e+12. What is the difference between the Taxes (in US$) of Lebanon in 2009 and the Taxes (in US$) of Suriname in 2011?
Give a very brief answer. 6.09e+12. What is the difference between the Taxes (in US$) in Madagascar in 2009 and the Taxes (in US$) in Suriname in 2011?
Your answer should be compact. 1.32e+12. What is the difference between the Taxes (in US$) in Georgia in 2009 and the Taxes (in US$) in Lebanon in 2012?
Offer a very short reply. -7.15e+12. What is the difference between the Taxes (in US$) in Georgia in 2009 and the Taxes (in US$) in Madagascar in 2012?
Offer a very short reply. -1.87e+12. What is the difference between the Taxes (in US$) of Georgia in 2009 and the Taxes (in US$) of Suriname in 2012?
Offer a terse response. 1.01e+09. What is the difference between the Taxes (in US$) in Lebanon in 2009 and the Taxes (in US$) in Madagascar in 2012?
Make the answer very short. 4.22e+12. What is the difference between the Taxes (in US$) in Lebanon in 2009 and the Taxes (in US$) in Suriname in 2012?
Provide a succinct answer. 6.09e+12. What is the difference between the Taxes (in US$) in Madagascar in 2009 and the Taxes (in US$) in Suriname in 2012?
Your response must be concise. 1.32e+12. What is the difference between the Taxes (in US$) of Georgia in 2009 and the Taxes (in US$) of Lebanon in 2013?
Offer a terse response. -6.08e+12. What is the difference between the Taxes (in US$) in Georgia in 2009 and the Taxes (in US$) in Madagascar in 2013?
Provide a short and direct response. -1.88e+12. What is the difference between the Taxes (in US$) of Georgia in 2009 and the Taxes (in US$) of Suriname in 2013?
Give a very brief answer. 8.98e+08. What is the difference between the Taxes (in US$) of Lebanon in 2009 and the Taxes (in US$) of Madagascar in 2013?
Keep it short and to the point. 4.21e+12. What is the difference between the Taxes (in US$) of Lebanon in 2009 and the Taxes (in US$) of Suriname in 2013?
Your response must be concise. 6.09e+12. What is the difference between the Taxes (in US$) in Madagascar in 2009 and the Taxes (in US$) in Suriname in 2013?
Ensure brevity in your answer.  1.32e+12. What is the difference between the Taxes (in US$) of Georgia in 2010 and the Taxes (in US$) of Lebanon in 2011?
Offer a terse response. -4.90e+12. What is the difference between the Taxes (in US$) of Georgia in 2010 and the Taxes (in US$) of Madagascar in 2011?
Ensure brevity in your answer.  -1.70e+12. What is the difference between the Taxes (in US$) of Georgia in 2010 and the Taxes (in US$) of Suriname in 2011?
Your answer should be very brief. 1.41e+09. What is the difference between the Taxes (in US$) in Lebanon in 2010 and the Taxes (in US$) in Madagascar in 2011?
Your response must be concise. 4.17e+12. What is the difference between the Taxes (in US$) in Lebanon in 2010 and the Taxes (in US$) in Suriname in 2011?
Offer a terse response. 5.86e+12. What is the difference between the Taxes (in US$) in Madagascar in 2010 and the Taxes (in US$) in Suriname in 2011?
Ensure brevity in your answer.  1.49e+12. What is the difference between the Taxes (in US$) of Georgia in 2010 and the Taxes (in US$) of Lebanon in 2012?
Your response must be concise. -7.15e+12. What is the difference between the Taxes (in US$) of Georgia in 2010 and the Taxes (in US$) of Madagascar in 2012?
Provide a short and direct response. -1.87e+12. What is the difference between the Taxes (in US$) of Georgia in 2010 and the Taxes (in US$) of Suriname in 2012?
Keep it short and to the point. 1.30e+09. What is the difference between the Taxes (in US$) of Lebanon in 2010 and the Taxes (in US$) of Madagascar in 2012?
Your answer should be compact. 3.99e+12. What is the difference between the Taxes (in US$) in Lebanon in 2010 and the Taxes (in US$) in Suriname in 2012?
Keep it short and to the point. 5.86e+12. What is the difference between the Taxes (in US$) in Madagascar in 2010 and the Taxes (in US$) in Suriname in 2012?
Provide a succinct answer. 1.49e+12. What is the difference between the Taxes (in US$) of Georgia in 2010 and the Taxes (in US$) of Lebanon in 2013?
Make the answer very short. -6.08e+12. What is the difference between the Taxes (in US$) in Georgia in 2010 and the Taxes (in US$) in Madagascar in 2013?
Provide a short and direct response. -1.88e+12. What is the difference between the Taxes (in US$) of Georgia in 2010 and the Taxes (in US$) of Suriname in 2013?
Your response must be concise. 1.19e+09. What is the difference between the Taxes (in US$) in Lebanon in 2010 and the Taxes (in US$) in Madagascar in 2013?
Your response must be concise. 3.98e+12. What is the difference between the Taxes (in US$) in Lebanon in 2010 and the Taxes (in US$) in Suriname in 2013?
Ensure brevity in your answer.  5.86e+12. What is the difference between the Taxes (in US$) of Madagascar in 2010 and the Taxes (in US$) of Suriname in 2013?
Ensure brevity in your answer.  1.49e+12. What is the difference between the Taxes (in US$) of Georgia in 2011 and the Taxes (in US$) of Lebanon in 2012?
Your answer should be very brief. -7.15e+12. What is the difference between the Taxes (in US$) in Georgia in 2011 and the Taxes (in US$) in Madagascar in 2012?
Your answer should be very brief. -1.87e+12. What is the difference between the Taxes (in US$) in Georgia in 2011 and the Taxes (in US$) in Suriname in 2012?
Make the answer very short. 1.94e+09. What is the difference between the Taxes (in US$) of Lebanon in 2011 and the Taxes (in US$) of Madagascar in 2012?
Provide a short and direct response. 3.03e+12. What is the difference between the Taxes (in US$) of Lebanon in 2011 and the Taxes (in US$) of Suriname in 2012?
Ensure brevity in your answer.  4.90e+12. What is the difference between the Taxes (in US$) in Madagascar in 2011 and the Taxes (in US$) in Suriname in 2012?
Your response must be concise. 1.70e+12. What is the difference between the Taxes (in US$) in Georgia in 2011 and the Taxes (in US$) in Lebanon in 2013?
Your answer should be very brief. -6.08e+12. What is the difference between the Taxes (in US$) in Georgia in 2011 and the Taxes (in US$) in Madagascar in 2013?
Give a very brief answer. -1.88e+12. What is the difference between the Taxes (in US$) of Georgia in 2011 and the Taxes (in US$) of Suriname in 2013?
Ensure brevity in your answer.  1.83e+09. What is the difference between the Taxes (in US$) in Lebanon in 2011 and the Taxes (in US$) in Madagascar in 2013?
Your response must be concise. 3.02e+12. What is the difference between the Taxes (in US$) in Lebanon in 2011 and the Taxes (in US$) in Suriname in 2013?
Provide a succinct answer. 4.90e+12. What is the difference between the Taxes (in US$) in Madagascar in 2011 and the Taxes (in US$) in Suriname in 2013?
Your answer should be very brief. 1.70e+12. What is the difference between the Taxes (in US$) of Georgia in 2012 and the Taxes (in US$) of Lebanon in 2013?
Provide a succinct answer. -6.08e+12. What is the difference between the Taxes (in US$) in Georgia in 2012 and the Taxes (in US$) in Madagascar in 2013?
Give a very brief answer. -1.88e+12. What is the difference between the Taxes (in US$) of Georgia in 2012 and the Taxes (in US$) of Suriname in 2013?
Give a very brief answer. 2.12e+09. What is the difference between the Taxes (in US$) in Lebanon in 2012 and the Taxes (in US$) in Madagascar in 2013?
Provide a short and direct response. 5.27e+12. What is the difference between the Taxes (in US$) in Lebanon in 2012 and the Taxes (in US$) in Suriname in 2013?
Provide a succinct answer. 7.15e+12. What is the difference between the Taxes (in US$) in Madagascar in 2012 and the Taxes (in US$) in Suriname in 2013?
Your answer should be very brief. 1.87e+12. What is the average Taxes (in US$) in Georgia per year?
Make the answer very short. 2.80e+09. What is the average Taxes (in US$) of Lebanon per year?
Make the answer very short. 4.87e+12. What is the average Taxes (in US$) of Madagascar per year?
Ensure brevity in your answer.  1.52e+12. What is the average Taxes (in US$) of Suriname per year?
Make the answer very short. 9.84e+08. In the year 2006, what is the difference between the Taxes (in US$) in Georgia and Taxes (in US$) in Lebanon?
Give a very brief answer. -2.56e+12. In the year 2006, what is the difference between the Taxes (in US$) in Georgia and Taxes (in US$) in Madagascar?
Keep it short and to the point. -1.01e+12. In the year 2006, what is the difference between the Taxes (in US$) in Georgia and Taxes (in US$) in Suriname?
Your answer should be very brief. 1.19e+09. In the year 2006, what is the difference between the Taxes (in US$) in Lebanon and Taxes (in US$) in Madagascar?
Your answer should be very brief. 1.55e+12. In the year 2006, what is the difference between the Taxes (in US$) in Lebanon and Taxes (in US$) in Suriname?
Your answer should be very brief. 2.57e+12. In the year 2006, what is the difference between the Taxes (in US$) in Madagascar and Taxes (in US$) in Suriname?
Offer a terse response. 1.01e+12. In the year 2007, what is the difference between the Taxes (in US$) in Georgia and Taxes (in US$) in Lebanon?
Provide a succinct answer. -3.31e+12. In the year 2007, what is the difference between the Taxes (in US$) in Georgia and Taxes (in US$) in Madagascar?
Provide a short and direct response. -1.23e+12. In the year 2007, what is the difference between the Taxes (in US$) of Georgia and Taxes (in US$) of Suriname?
Your answer should be compact. 1.73e+09. In the year 2007, what is the difference between the Taxes (in US$) in Lebanon and Taxes (in US$) in Madagascar?
Give a very brief answer. 2.08e+12. In the year 2007, what is the difference between the Taxes (in US$) in Lebanon and Taxes (in US$) in Suriname?
Your response must be concise. 3.31e+12. In the year 2007, what is the difference between the Taxes (in US$) in Madagascar and Taxes (in US$) in Suriname?
Your answer should be compact. 1.23e+12. In the year 2008, what is the difference between the Taxes (in US$) in Georgia and Taxes (in US$) in Lebanon?
Make the answer very short. -2.99e+12. In the year 2008, what is the difference between the Taxes (in US$) in Georgia and Taxes (in US$) in Madagascar?
Your answer should be compact. -1.63e+12. In the year 2008, what is the difference between the Taxes (in US$) of Georgia and Taxes (in US$) of Suriname?
Make the answer very short. 1.89e+09. In the year 2008, what is the difference between the Taxes (in US$) of Lebanon and Taxes (in US$) of Madagascar?
Give a very brief answer. 1.37e+12. In the year 2008, what is the difference between the Taxes (in US$) in Lebanon and Taxes (in US$) in Suriname?
Provide a short and direct response. 3.00e+12. In the year 2008, what is the difference between the Taxes (in US$) of Madagascar and Taxes (in US$) of Suriname?
Your response must be concise. 1.63e+12. In the year 2009, what is the difference between the Taxes (in US$) of Georgia and Taxes (in US$) of Lebanon?
Provide a short and direct response. -6.09e+12. In the year 2009, what is the difference between the Taxes (in US$) of Georgia and Taxes (in US$) of Madagascar?
Offer a terse response. -1.32e+12. In the year 2009, what is the difference between the Taxes (in US$) of Georgia and Taxes (in US$) of Suriname?
Offer a terse response. 1.57e+09. In the year 2009, what is the difference between the Taxes (in US$) in Lebanon and Taxes (in US$) in Madagascar?
Offer a very short reply. 4.78e+12. In the year 2009, what is the difference between the Taxes (in US$) of Lebanon and Taxes (in US$) of Suriname?
Ensure brevity in your answer.  6.09e+12. In the year 2009, what is the difference between the Taxes (in US$) in Madagascar and Taxes (in US$) in Suriname?
Make the answer very short. 1.32e+12. In the year 2010, what is the difference between the Taxes (in US$) in Georgia and Taxes (in US$) in Lebanon?
Keep it short and to the point. -5.86e+12. In the year 2010, what is the difference between the Taxes (in US$) in Georgia and Taxes (in US$) in Madagascar?
Offer a terse response. -1.49e+12. In the year 2010, what is the difference between the Taxes (in US$) in Georgia and Taxes (in US$) in Suriname?
Your answer should be compact. 1.87e+09. In the year 2010, what is the difference between the Taxes (in US$) of Lebanon and Taxes (in US$) of Madagascar?
Your answer should be compact. 4.38e+12. In the year 2010, what is the difference between the Taxes (in US$) of Lebanon and Taxes (in US$) of Suriname?
Your answer should be very brief. 5.87e+12. In the year 2010, what is the difference between the Taxes (in US$) in Madagascar and Taxes (in US$) in Suriname?
Your answer should be very brief. 1.49e+12. In the year 2011, what is the difference between the Taxes (in US$) of Georgia and Taxes (in US$) of Lebanon?
Your answer should be compact. -4.90e+12. In the year 2011, what is the difference between the Taxes (in US$) of Georgia and Taxes (in US$) of Madagascar?
Your response must be concise. -1.70e+12. In the year 2011, what is the difference between the Taxes (in US$) of Georgia and Taxes (in US$) of Suriname?
Keep it short and to the point. 2.05e+09. In the year 2011, what is the difference between the Taxes (in US$) in Lebanon and Taxes (in US$) in Madagascar?
Provide a succinct answer. 3.20e+12. In the year 2011, what is the difference between the Taxes (in US$) in Lebanon and Taxes (in US$) in Suriname?
Keep it short and to the point. 4.90e+12. In the year 2011, what is the difference between the Taxes (in US$) of Madagascar and Taxes (in US$) of Suriname?
Your response must be concise. 1.70e+12. In the year 2012, what is the difference between the Taxes (in US$) of Georgia and Taxes (in US$) of Lebanon?
Offer a very short reply. -7.15e+12. In the year 2012, what is the difference between the Taxes (in US$) of Georgia and Taxes (in US$) of Madagascar?
Make the answer very short. -1.87e+12. In the year 2012, what is the difference between the Taxes (in US$) in Georgia and Taxes (in US$) in Suriname?
Offer a terse response. 2.24e+09. In the year 2012, what is the difference between the Taxes (in US$) of Lebanon and Taxes (in US$) of Madagascar?
Provide a succinct answer. 5.28e+12. In the year 2012, what is the difference between the Taxes (in US$) in Lebanon and Taxes (in US$) in Suriname?
Provide a succinct answer. 7.15e+12. In the year 2012, what is the difference between the Taxes (in US$) in Madagascar and Taxes (in US$) in Suriname?
Ensure brevity in your answer.  1.87e+12. In the year 2013, what is the difference between the Taxes (in US$) of Georgia and Taxes (in US$) of Lebanon?
Offer a very short reply. -6.08e+12. In the year 2013, what is the difference between the Taxes (in US$) of Georgia and Taxes (in US$) of Madagascar?
Your answer should be very brief. -1.88e+12. In the year 2013, what is the difference between the Taxes (in US$) of Georgia and Taxes (in US$) of Suriname?
Your answer should be very brief. 1.97e+09. In the year 2013, what is the difference between the Taxes (in US$) in Lebanon and Taxes (in US$) in Madagascar?
Keep it short and to the point. 4.20e+12. In the year 2013, what is the difference between the Taxes (in US$) of Lebanon and Taxes (in US$) of Suriname?
Offer a terse response. 6.08e+12. In the year 2013, what is the difference between the Taxes (in US$) of Madagascar and Taxes (in US$) of Suriname?
Give a very brief answer. 1.88e+12. What is the ratio of the Taxes (in US$) in Georgia in 2006 to that in 2007?
Your response must be concise. 0.73. What is the ratio of the Taxes (in US$) in Lebanon in 2006 to that in 2007?
Ensure brevity in your answer.  0.78. What is the ratio of the Taxes (in US$) of Madagascar in 2006 to that in 2007?
Provide a succinct answer. 0.82. What is the ratio of the Taxes (in US$) in Suriname in 2006 to that in 2007?
Provide a succinct answer. 0.85. What is the ratio of the Taxes (in US$) of Georgia in 2006 to that in 2008?
Your answer should be very brief. 0.68. What is the ratio of the Taxes (in US$) of Lebanon in 2006 to that in 2008?
Your response must be concise. 0.86. What is the ratio of the Taxes (in US$) of Madagascar in 2006 to that in 2008?
Ensure brevity in your answer.  0.62. What is the ratio of the Taxes (in US$) in Suriname in 2006 to that in 2008?
Offer a very short reply. 0.83. What is the ratio of the Taxes (in US$) in Georgia in 2006 to that in 2009?
Provide a short and direct response. 0.71. What is the ratio of the Taxes (in US$) of Lebanon in 2006 to that in 2009?
Your response must be concise. 0.42. What is the ratio of the Taxes (in US$) in Madagascar in 2006 to that in 2009?
Provide a short and direct response. 0.77. What is the ratio of the Taxes (in US$) in Suriname in 2006 to that in 2009?
Your response must be concise. 0.63. What is the ratio of the Taxes (in US$) of Georgia in 2006 to that in 2010?
Your answer should be very brief. 0.64. What is the ratio of the Taxes (in US$) in Lebanon in 2006 to that in 2010?
Your answer should be compact. 0.44. What is the ratio of the Taxes (in US$) of Madagascar in 2006 to that in 2010?
Provide a short and direct response. 0.68. What is the ratio of the Taxes (in US$) of Suriname in 2006 to that in 2010?
Offer a very short reply. 0.64. What is the ratio of the Taxes (in US$) of Georgia in 2006 to that in 2011?
Provide a short and direct response. 0.52. What is the ratio of the Taxes (in US$) of Lebanon in 2006 to that in 2011?
Provide a short and direct response. 0.52. What is the ratio of the Taxes (in US$) of Madagascar in 2006 to that in 2011?
Your answer should be very brief. 0.6. What is the ratio of the Taxes (in US$) of Suriname in 2006 to that in 2011?
Make the answer very short. 0.42. What is the ratio of the Taxes (in US$) of Georgia in 2006 to that in 2012?
Make the answer very short. 0.48. What is the ratio of the Taxes (in US$) in Lebanon in 2006 to that in 2012?
Offer a very short reply. 0.36. What is the ratio of the Taxes (in US$) in Madagascar in 2006 to that in 2012?
Provide a succinct answer. 0.54. What is the ratio of the Taxes (in US$) in Suriname in 2006 to that in 2012?
Ensure brevity in your answer.  0.39. What is the ratio of the Taxes (in US$) in Georgia in 2006 to that in 2013?
Provide a short and direct response. 0.5. What is the ratio of the Taxes (in US$) of Lebanon in 2006 to that in 2013?
Your answer should be compact. 0.42. What is the ratio of the Taxes (in US$) of Madagascar in 2006 to that in 2013?
Provide a short and direct response. 0.54. What is the ratio of the Taxes (in US$) of Suriname in 2006 to that in 2013?
Keep it short and to the point. 0.36. What is the ratio of the Taxes (in US$) of Lebanon in 2007 to that in 2008?
Your response must be concise. 1.1. What is the ratio of the Taxes (in US$) in Madagascar in 2007 to that in 2008?
Give a very brief answer. 0.75. What is the ratio of the Taxes (in US$) of Suriname in 2007 to that in 2008?
Make the answer very short. 0.98. What is the ratio of the Taxes (in US$) in Georgia in 2007 to that in 2009?
Ensure brevity in your answer.  0.98. What is the ratio of the Taxes (in US$) in Lebanon in 2007 to that in 2009?
Your answer should be compact. 0.54. What is the ratio of the Taxes (in US$) in Madagascar in 2007 to that in 2009?
Keep it short and to the point. 0.93. What is the ratio of the Taxes (in US$) of Suriname in 2007 to that in 2009?
Offer a terse response. 0.75. What is the ratio of the Taxes (in US$) in Georgia in 2007 to that in 2010?
Offer a very short reply. 0.87. What is the ratio of the Taxes (in US$) in Lebanon in 2007 to that in 2010?
Your answer should be compact. 0.56. What is the ratio of the Taxes (in US$) of Madagascar in 2007 to that in 2010?
Provide a succinct answer. 0.82. What is the ratio of the Taxes (in US$) in Suriname in 2007 to that in 2010?
Your response must be concise. 0.76. What is the ratio of the Taxes (in US$) in Georgia in 2007 to that in 2011?
Provide a succinct answer. 0.71. What is the ratio of the Taxes (in US$) in Lebanon in 2007 to that in 2011?
Your answer should be compact. 0.68. What is the ratio of the Taxes (in US$) in Madagascar in 2007 to that in 2011?
Your response must be concise. 0.72. What is the ratio of the Taxes (in US$) in Suriname in 2007 to that in 2011?
Your response must be concise. 0.49. What is the ratio of the Taxes (in US$) of Georgia in 2007 to that in 2012?
Ensure brevity in your answer.  0.65. What is the ratio of the Taxes (in US$) in Lebanon in 2007 to that in 2012?
Your answer should be compact. 0.46. What is the ratio of the Taxes (in US$) of Madagascar in 2007 to that in 2012?
Provide a short and direct response. 0.66. What is the ratio of the Taxes (in US$) in Suriname in 2007 to that in 2012?
Keep it short and to the point. 0.45. What is the ratio of the Taxes (in US$) in Georgia in 2007 to that in 2013?
Your answer should be very brief. 0.68. What is the ratio of the Taxes (in US$) of Lebanon in 2007 to that in 2013?
Your answer should be very brief. 0.54. What is the ratio of the Taxes (in US$) of Madagascar in 2007 to that in 2013?
Your answer should be very brief. 0.65. What is the ratio of the Taxes (in US$) of Suriname in 2007 to that in 2013?
Your answer should be very brief. 0.42. What is the ratio of the Taxes (in US$) of Georgia in 2008 to that in 2009?
Provide a succinct answer. 1.05. What is the ratio of the Taxes (in US$) in Lebanon in 2008 to that in 2009?
Your answer should be compact. 0.49. What is the ratio of the Taxes (in US$) of Madagascar in 2008 to that in 2009?
Your answer should be compact. 1.24. What is the ratio of the Taxes (in US$) in Suriname in 2008 to that in 2009?
Offer a terse response. 0.76. What is the ratio of the Taxes (in US$) in Georgia in 2008 to that in 2010?
Give a very brief answer. 0.94. What is the ratio of the Taxes (in US$) in Lebanon in 2008 to that in 2010?
Your response must be concise. 0.51. What is the ratio of the Taxes (in US$) of Madagascar in 2008 to that in 2010?
Your answer should be compact. 1.09. What is the ratio of the Taxes (in US$) of Suriname in 2008 to that in 2010?
Your response must be concise. 0.77. What is the ratio of the Taxes (in US$) of Georgia in 2008 to that in 2011?
Make the answer very short. 0.76. What is the ratio of the Taxes (in US$) in Lebanon in 2008 to that in 2011?
Make the answer very short. 0.61. What is the ratio of the Taxes (in US$) of Madagascar in 2008 to that in 2011?
Your answer should be compact. 0.96. What is the ratio of the Taxes (in US$) of Suriname in 2008 to that in 2011?
Give a very brief answer. 0.5. What is the ratio of the Taxes (in US$) of Georgia in 2008 to that in 2012?
Your answer should be very brief. 0.7. What is the ratio of the Taxes (in US$) in Lebanon in 2008 to that in 2012?
Your response must be concise. 0.42. What is the ratio of the Taxes (in US$) of Madagascar in 2008 to that in 2012?
Provide a succinct answer. 0.87. What is the ratio of the Taxes (in US$) in Suriname in 2008 to that in 2012?
Your answer should be very brief. 0.46. What is the ratio of the Taxes (in US$) of Georgia in 2008 to that in 2013?
Your answer should be very brief. 0.73. What is the ratio of the Taxes (in US$) in Lebanon in 2008 to that in 2013?
Ensure brevity in your answer.  0.49. What is the ratio of the Taxes (in US$) in Madagascar in 2008 to that in 2013?
Make the answer very short. 0.87. What is the ratio of the Taxes (in US$) of Suriname in 2008 to that in 2013?
Make the answer very short. 0.43. What is the ratio of the Taxes (in US$) of Georgia in 2009 to that in 2010?
Make the answer very short. 0.89. What is the ratio of the Taxes (in US$) of Lebanon in 2009 to that in 2010?
Make the answer very short. 1.04. What is the ratio of the Taxes (in US$) of Madagascar in 2009 to that in 2010?
Provide a succinct answer. 0.89. What is the ratio of the Taxes (in US$) in Suriname in 2009 to that in 2010?
Provide a succinct answer. 1.02. What is the ratio of the Taxes (in US$) in Georgia in 2009 to that in 2011?
Your answer should be compact. 0.72. What is the ratio of the Taxes (in US$) in Lebanon in 2009 to that in 2011?
Your answer should be very brief. 1.24. What is the ratio of the Taxes (in US$) of Madagascar in 2009 to that in 2011?
Ensure brevity in your answer.  0.78. What is the ratio of the Taxes (in US$) in Suriname in 2009 to that in 2011?
Provide a short and direct response. 0.66. What is the ratio of the Taxes (in US$) in Georgia in 2009 to that in 2012?
Give a very brief answer. 0.67. What is the ratio of the Taxes (in US$) in Lebanon in 2009 to that in 2012?
Provide a succinct answer. 0.85. What is the ratio of the Taxes (in US$) of Madagascar in 2009 to that in 2012?
Offer a very short reply. 0.7. What is the ratio of the Taxes (in US$) of Suriname in 2009 to that in 2012?
Provide a succinct answer. 0.61. What is the ratio of the Taxes (in US$) of Georgia in 2009 to that in 2013?
Provide a succinct answer. 0.69. What is the ratio of the Taxes (in US$) of Lebanon in 2009 to that in 2013?
Keep it short and to the point. 1. What is the ratio of the Taxes (in US$) in Madagascar in 2009 to that in 2013?
Provide a short and direct response. 0.7. What is the ratio of the Taxes (in US$) of Suriname in 2009 to that in 2013?
Your answer should be compact. 0.56. What is the ratio of the Taxes (in US$) in Georgia in 2010 to that in 2011?
Give a very brief answer. 0.81. What is the ratio of the Taxes (in US$) of Lebanon in 2010 to that in 2011?
Give a very brief answer. 1.2. What is the ratio of the Taxes (in US$) of Madagascar in 2010 to that in 2011?
Your answer should be compact. 0.88. What is the ratio of the Taxes (in US$) in Suriname in 2010 to that in 2011?
Offer a terse response. 0.65. What is the ratio of the Taxes (in US$) in Georgia in 2010 to that in 2012?
Provide a short and direct response. 0.75. What is the ratio of the Taxes (in US$) of Lebanon in 2010 to that in 2012?
Make the answer very short. 0.82. What is the ratio of the Taxes (in US$) in Madagascar in 2010 to that in 2012?
Give a very brief answer. 0.8. What is the ratio of the Taxes (in US$) of Suriname in 2010 to that in 2012?
Your answer should be very brief. 0.6. What is the ratio of the Taxes (in US$) of Georgia in 2010 to that in 2013?
Keep it short and to the point. 0.78. What is the ratio of the Taxes (in US$) of Lebanon in 2010 to that in 2013?
Offer a terse response. 0.96. What is the ratio of the Taxes (in US$) in Madagascar in 2010 to that in 2013?
Provide a short and direct response. 0.79. What is the ratio of the Taxes (in US$) of Suriname in 2010 to that in 2013?
Keep it short and to the point. 0.55. What is the ratio of the Taxes (in US$) of Georgia in 2011 to that in 2012?
Provide a short and direct response. 0.92. What is the ratio of the Taxes (in US$) of Lebanon in 2011 to that in 2012?
Ensure brevity in your answer.  0.69. What is the ratio of the Taxes (in US$) of Madagascar in 2011 to that in 2012?
Provide a short and direct response. 0.91. What is the ratio of the Taxes (in US$) in Suriname in 2011 to that in 2012?
Give a very brief answer. 0.93. What is the ratio of the Taxes (in US$) of Georgia in 2011 to that in 2013?
Give a very brief answer. 0.96. What is the ratio of the Taxes (in US$) of Lebanon in 2011 to that in 2013?
Your answer should be very brief. 0.81. What is the ratio of the Taxes (in US$) in Madagascar in 2011 to that in 2013?
Offer a very short reply. 0.9. What is the ratio of the Taxes (in US$) of Suriname in 2011 to that in 2013?
Keep it short and to the point. 0.86. What is the ratio of the Taxes (in US$) in Georgia in 2012 to that in 2013?
Make the answer very short. 1.04. What is the ratio of the Taxes (in US$) in Lebanon in 2012 to that in 2013?
Your answer should be compact. 1.18. What is the ratio of the Taxes (in US$) of Suriname in 2012 to that in 2013?
Ensure brevity in your answer.  0.92. What is the difference between the highest and the second highest Taxes (in US$) in Georgia?
Provide a succinct answer. 1.50e+08. What is the difference between the highest and the second highest Taxes (in US$) of Lebanon?
Provide a short and direct response. 1.06e+12. What is the difference between the highest and the second highest Taxes (in US$) in Madagascar?
Ensure brevity in your answer.  9.89e+09. What is the difference between the highest and the second highest Taxes (in US$) in Suriname?
Give a very brief answer. 1.16e+08. What is the difference between the highest and the lowest Taxes (in US$) of Georgia?
Offer a terse response. 1.92e+09. What is the difference between the highest and the lowest Taxes (in US$) of Lebanon?
Make the answer very short. 4.59e+12. What is the difference between the highest and the lowest Taxes (in US$) of Madagascar?
Keep it short and to the point. 8.71e+11. What is the difference between the highest and the lowest Taxes (in US$) of Suriname?
Your answer should be compact. 9.91e+08. 